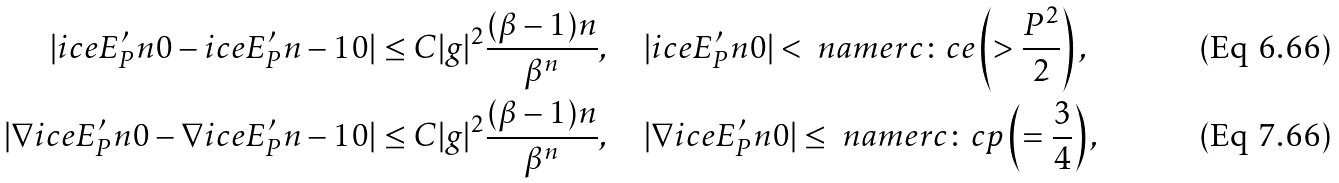Convert formula to latex. <formula><loc_0><loc_0><loc_500><loc_500>| \sl i c e { E ^ { \prime } _ { P } } { n } { 0 } - \sl i c e { E ^ { \prime } _ { P } } { n - 1 } { 0 } | & \leq C | g | ^ { 2 } \frac { ( \beta - 1 ) n } { \beta ^ { n } } , \quad | \sl i c e { E ^ { \prime } _ { P } } { n } { 0 } | < \ n a m e r { c \colon c e } \left ( > \frac { P ^ { 2 } } { 2 } \right ) , \\ | \nabla \sl i c e { E ^ { \prime } _ { P } } { n } { 0 } - \nabla \sl i c e { E ^ { \prime } _ { P } } { n - 1 } { 0 } | & \leq C | g | ^ { 2 } \frac { ( \beta - 1 ) n } { \beta ^ { n } } , \quad | \nabla \sl i c e { E ^ { \prime } _ { P } } { n } { 0 } | \leq \ n a m e r { c \colon c p } \left ( = \frac { 3 } { 4 } \right ) ,</formula> 